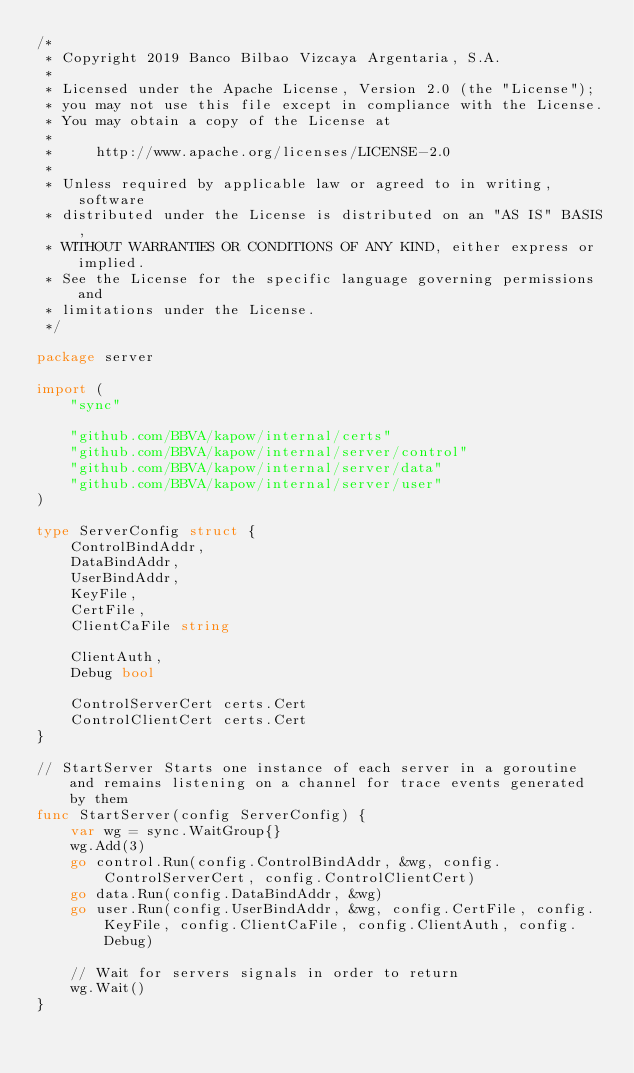Convert code to text. <code><loc_0><loc_0><loc_500><loc_500><_Go_>/*
 * Copyright 2019 Banco Bilbao Vizcaya Argentaria, S.A.
 *
 * Licensed under the Apache License, Version 2.0 (the "License");
 * you may not use this file except in compliance with the License.
 * You may obtain a copy of the License at
 *
 *     http://www.apache.org/licenses/LICENSE-2.0
 *
 * Unless required by applicable law or agreed to in writing, software
 * distributed under the License is distributed on an "AS IS" BASIS,
 * WITHOUT WARRANTIES OR CONDITIONS OF ANY KIND, either express or implied.
 * See the License for the specific language governing permissions and
 * limitations under the License.
 */

package server

import (
	"sync"

	"github.com/BBVA/kapow/internal/certs"
	"github.com/BBVA/kapow/internal/server/control"
	"github.com/BBVA/kapow/internal/server/data"
	"github.com/BBVA/kapow/internal/server/user"
)

type ServerConfig struct {
	ControlBindAddr,
	DataBindAddr,
	UserBindAddr,
	KeyFile,
	CertFile,
	ClientCaFile string

	ClientAuth,
	Debug bool

	ControlServerCert certs.Cert
	ControlClientCert certs.Cert
}

// StartServer Starts one instance of each server in a goroutine and remains listening on a channel for trace events generated by them
func StartServer(config ServerConfig) {
	var wg = sync.WaitGroup{}
	wg.Add(3)
	go control.Run(config.ControlBindAddr, &wg, config.ControlServerCert, config.ControlClientCert)
	go data.Run(config.DataBindAddr, &wg)
	go user.Run(config.UserBindAddr, &wg, config.CertFile, config.KeyFile, config.ClientCaFile, config.ClientAuth, config.Debug)

	// Wait for servers signals in order to return
	wg.Wait()
}
</code> 